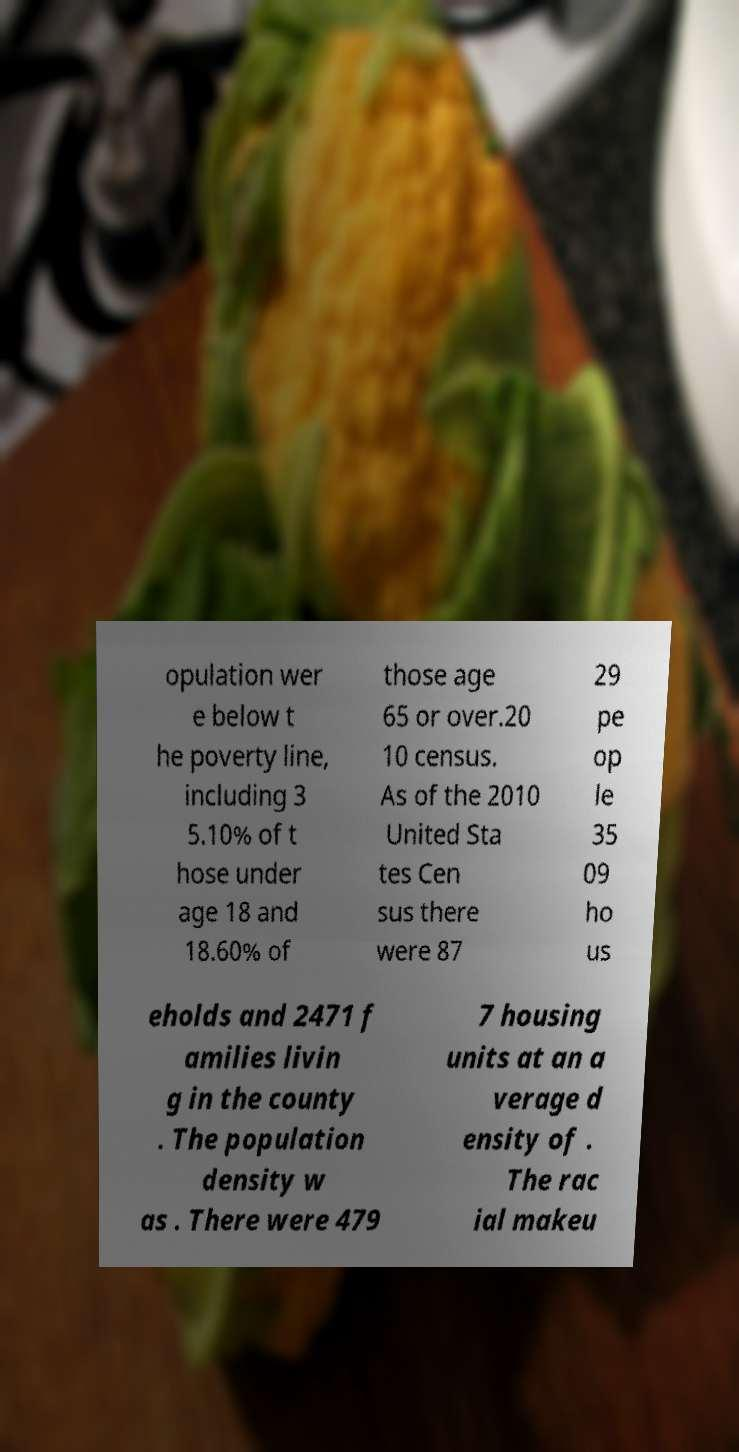Could you assist in decoding the text presented in this image and type it out clearly? opulation wer e below t he poverty line, including 3 5.10% of t hose under age 18 and 18.60% of those age 65 or over.20 10 census. As of the 2010 United Sta tes Cen sus there were 87 29 pe op le 35 09 ho us eholds and 2471 f amilies livin g in the county . The population density w as . There were 479 7 housing units at an a verage d ensity of . The rac ial makeu 